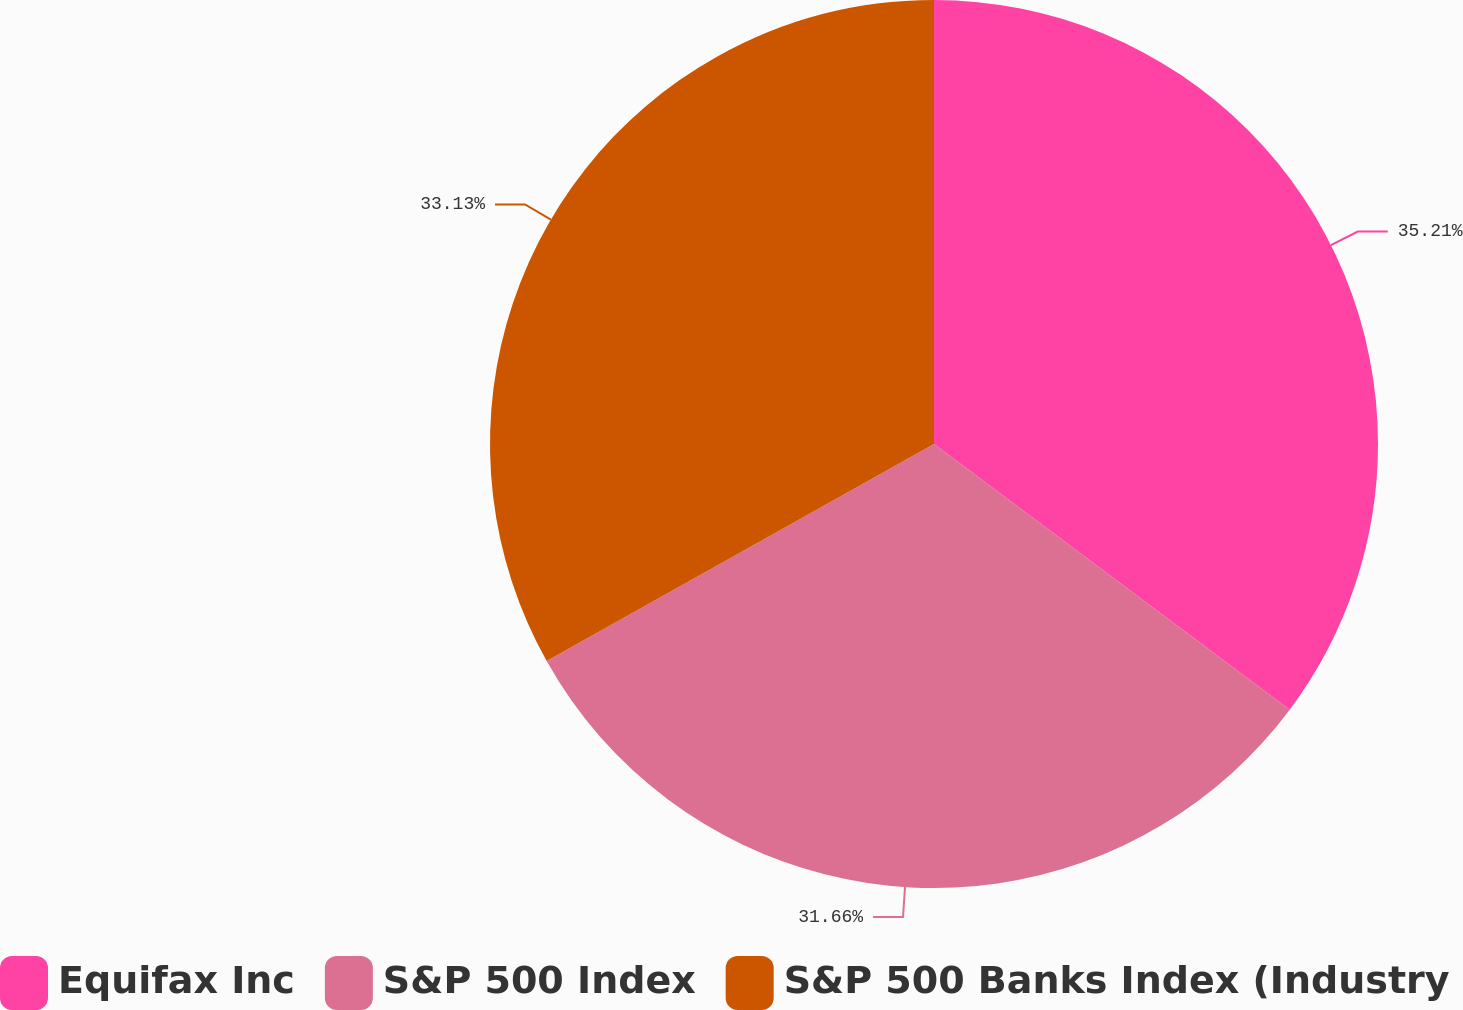<chart> <loc_0><loc_0><loc_500><loc_500><pie_chart><fcel>Equifax Inc<fcel>S&P 500 Index<fcel>S&P 500 Banks Index (Industry<nl><fcel>35.21%<fcel>31.66%<fcel>33.13%<nl></chart> 